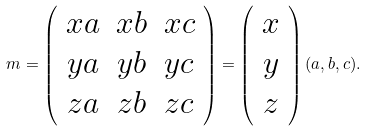Convert formula to latex. <formula><loc_0><loc_0><loc_500><loc_500>m = \left ( \begin{array} { c c c } x a & x b & x c \\ y a & y b & y c \\ z a & z b & z c \end{array} \right ) = \left ( \begin{array} { c } x \\ y \\ z \end{array} \right ) ( a , b , c ) .</formula> 